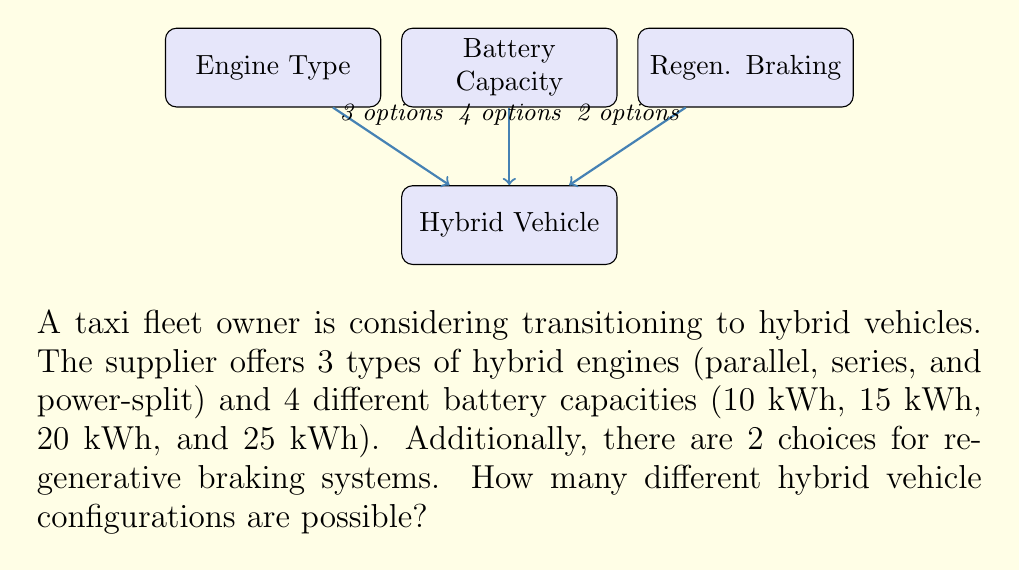Give your solution to this math problem. To solve this problem, we'll use the multiplication principle of counting. This principle states that if we have a sequence of independent choices, the total number of possible outcomes is the product of the number of possibilities for each choice.

Let's break down the available options:
1. Engine types: 3 options
2. Battery capacities: 4 options
3. Regenerative braking systems: 2 options

Each of these choices can be made independently of the others. This means we can multiply the number of options for each choice to get the total number of possible configurations.

Number of configurations = (Number of engine types) × (Number of battery capacities) × (Number of regenerative braking systems)

$$ \text{Total configurations} = 3 \times 4 \times 2 $$

Now, let's calculate:

$$ \text{Total configurations} = 3 \times 4 \times 2 = 24 $$

Therefore, there are 24 different possible hybrid vehicle configurations based on the available options.
Answer: 24 